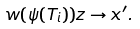<formula> <loc_0><loc_0><loc_500><loc_500>w ( \psi ( T _ { i } ) ) z \to x ^ { \prime } .</formula> 